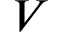<formula> <loc_0><loc_0><loc_500><loc_500>V</formula> 